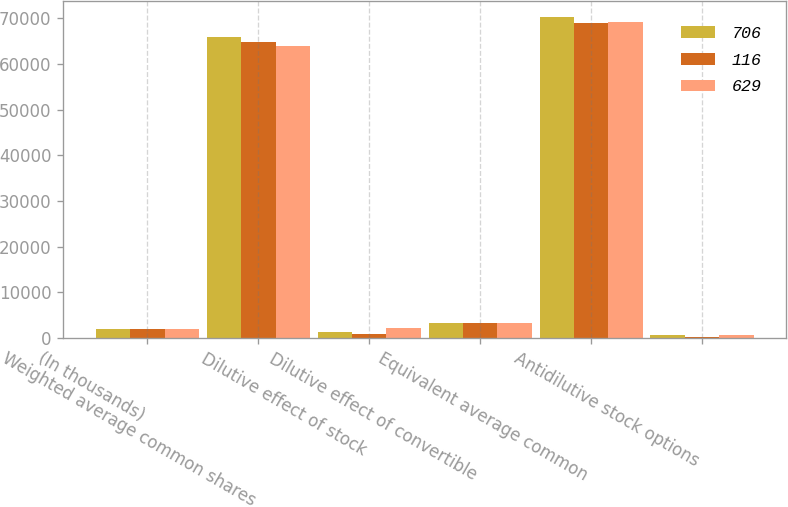Convert chart. <chart><loc_0><loc_0><loc_500><loc_500><stacked_bar_chart><ecel><fcel>(In thousands)<fcel>Weighted average common shares<fcel>Dilutive effect of stock<fcel>Dilutive effect of convertible<fcel>Equivalent average common<fcel>Antidilutive stock options<nl><fcel>706<fcel>2007<fcel>65840<fcel>1242<fcel>3230<fcel>70312<fcel>629<nl><fcel>116<fcel>2006<fcel>64856<fcel>862<fcel>3228<fcel>68946<fcel>116<nl><fcel>629<fcel>2005<fcel>63857<fcel>2206<fcel>3226<fcel>69289<fcel>706<nl></chart> 